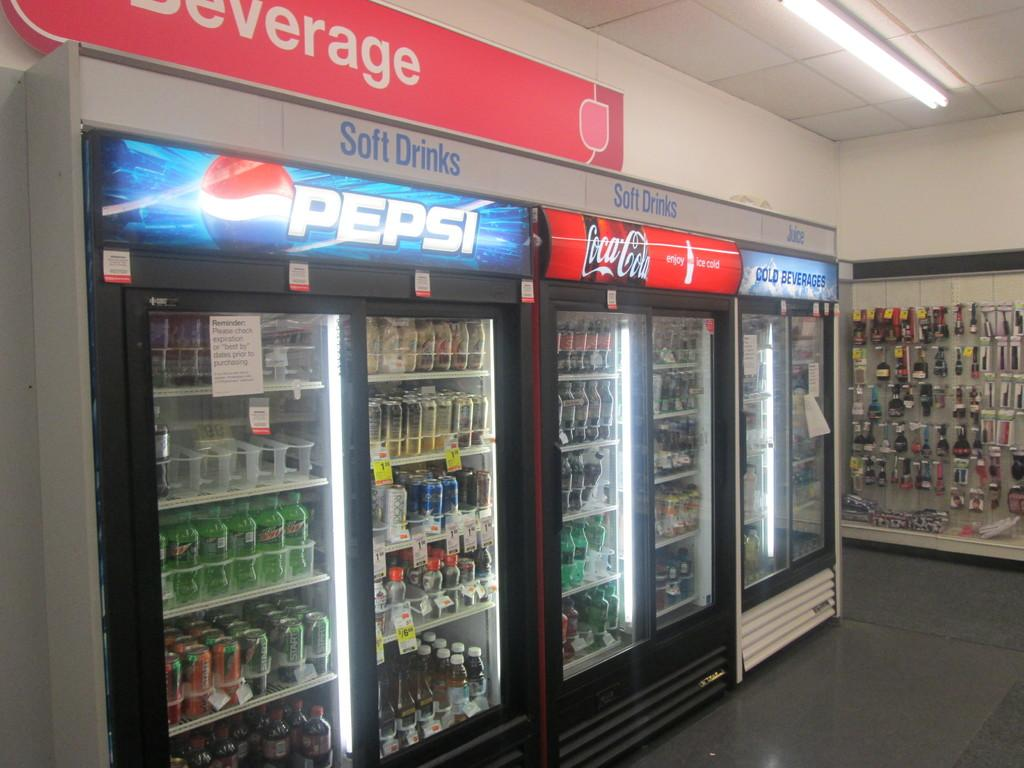Provide a one-sentence caption for the provided image. The beverage coolers are located underneath the beverage signage. 